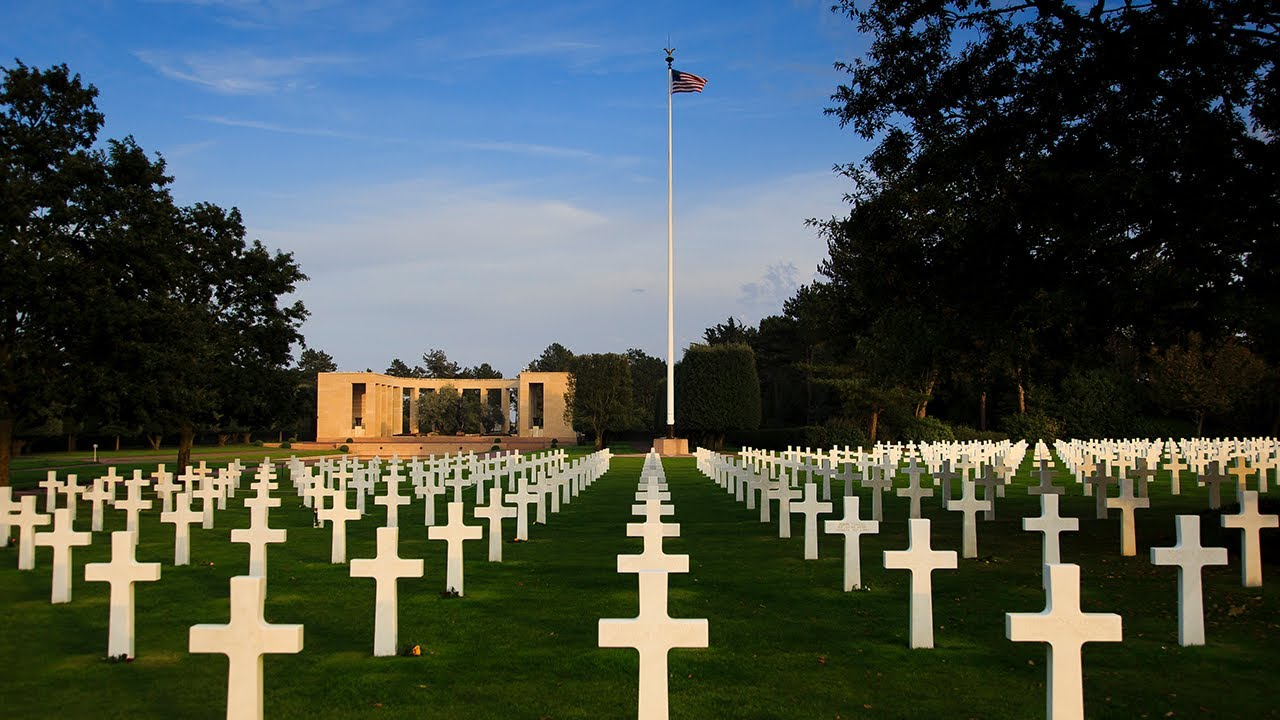Can you explain why the crosses are arranged in such neat rows? The crosses are arranged in neat rows to maintain a sense of order and dignity at the cemetery. This precise arrangement allows for a visual representation of the vast number of lives lost, simultaneously offering a path for visitors to walk through and pay their respects to individual soldiers without disrupting the overall symmetry and peacefulness of the sacred ground. 